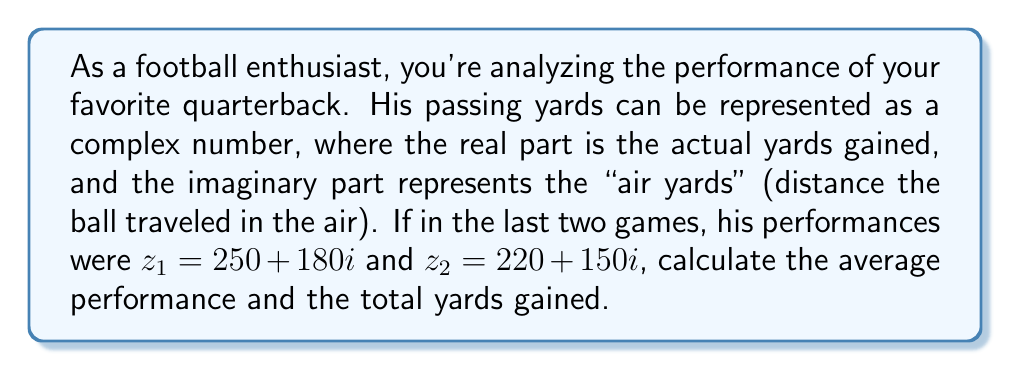Can you answer this question? To solve this problem, we'll use complex number operations:

1. Calculate the average performance:
   The average of two complex numbers is given by $\frac{z_1 + z_2}{2}$
   
   $$\begin{align}
   \text{Average} &= \frac{(250 + 180i) + (220 + 150i)}{2} \\
   &= \frac{(250 + 220) + (180 + 150)i}{2} \\
   &= \frac{470 + 330i}{2} \\
   &= 235 + 165i
   \end{align}$$

2. Calculate the total yards gained:
   To find the total actual yards, we sum the real parts of $z_1$ and $z_2$
   
   $$\begin{align}
   \text{Total yards} &= \text{Re}(z_1) + \text{Re}(z_2) \\
   &= 250 + 220 \\
   &= 470
   \end{align}$$

Therefore, the average performance is $235 + 165i$, and the total yards gained is 470.
Answer: Average: $235 + 165i$; Total yards: 470 